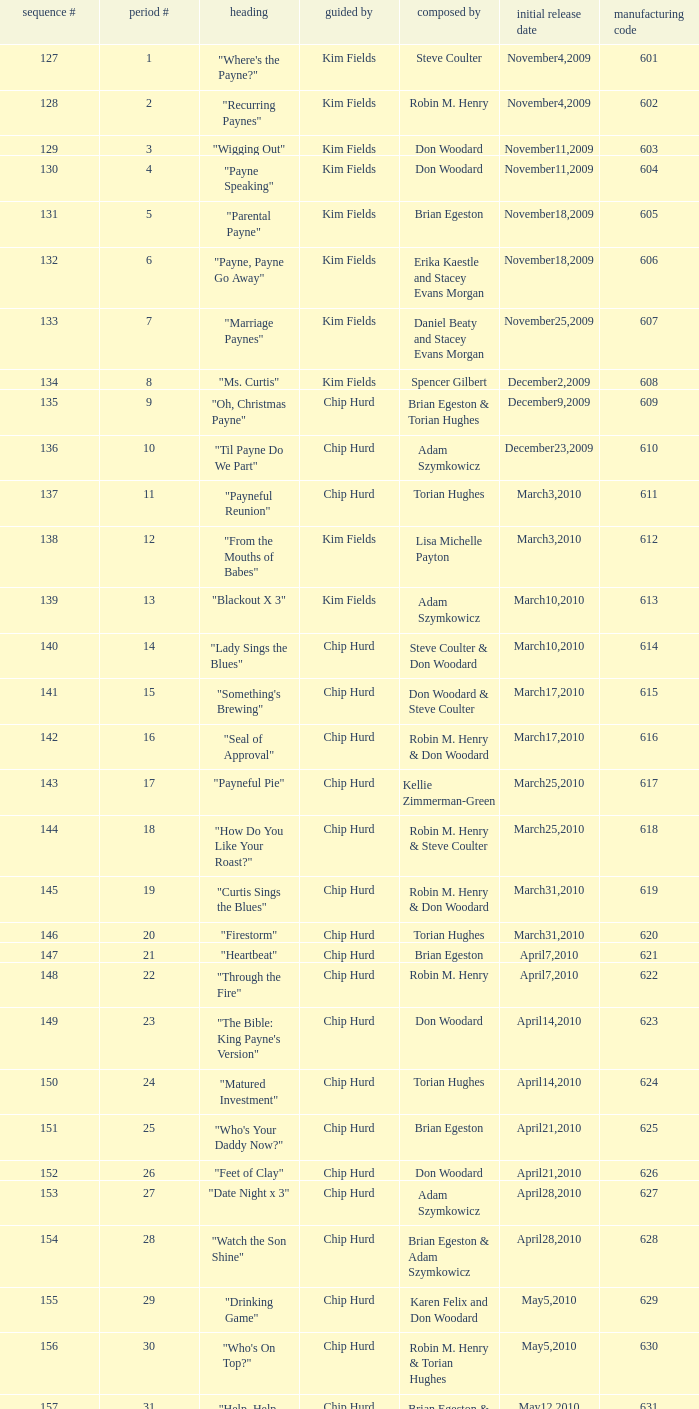What is the original air date of the episode written by Karen Felix and Don Woodard? May5,2010. 